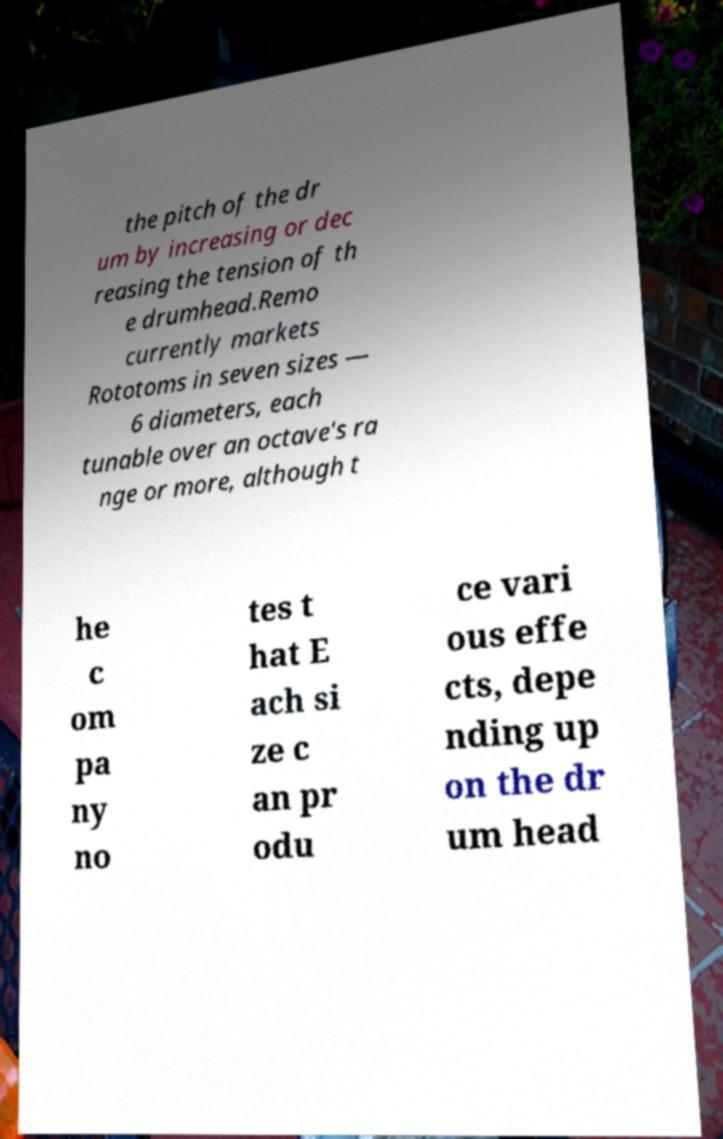Please identify and transcribe the text found in this image. the pitch of the dr um by increasing or dec reasing the tension of th e drumhead.Remo currently markets Rototoms in seven sizes — 6 diameters, each tunable over an octave's ra nge or more, although t he c om pa ny no tes t hat E ach si ze c an pr odu ce vari ous effe cts, depe nding up on the dr um head 